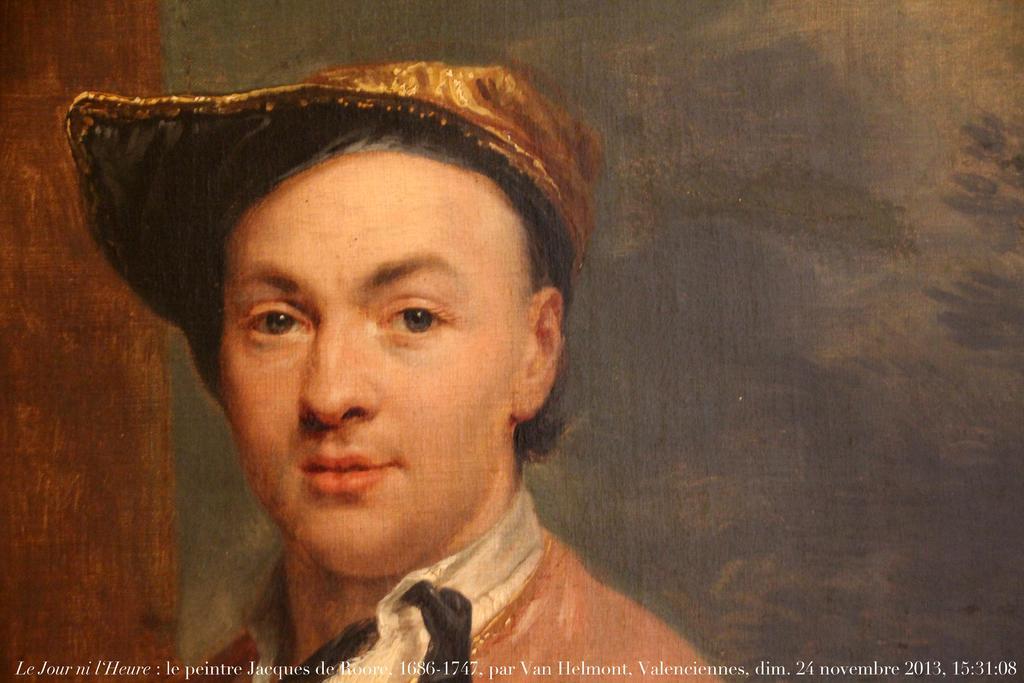Please provide a concise description of this image. As we can see in the image there is a painting of a person wearing cap. 